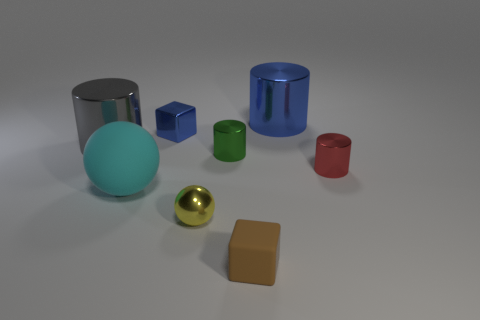There is a blue metallic object in front of the big blue object; is it the same shape as the metallic object that is to the right of the large blue metal thing?
Ensure brevity in your answer.  No. There is a big thing that is the same color as the shiny cube; what is it made of?
Your answer should be compact. Metal. Is there a small blue object?
Your answer should be very brief. Yes. What is the material of the yellow thing that is the same shape as the cyan object?
Offer a very short reply. Metal. There is a small yellow metallic thing; are there any small red cylinders on the right side of it?
Provide a succinct answer. Yes. Do the small blue object that is in front of the big blue metal cylinder and the large gray cylinder have the same material?
Your answer should be very brief. Yes. Is there a metal sphere of the same color as the big rubber sphere?
Your answer should be very brief. No. There is a big gray object; what shape is it?
Offer a very short reply. Cylinder. What is the color of the small cylinder that is to the left of the tiny shiny thing to the right of the large blue metallic thing?
Offer a very short reply. Green. How big is the object that is left of the big rubber object?
Provide a succinct answer. Large. 